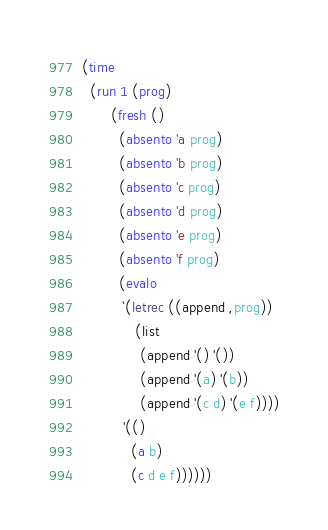Convert code to text. <code><loc_0><loc_0><loc_500><loc_500><_Scheme_>
(time
  (run 1 (prog)
       (fresh ()
         (absento 'a prog)
         (absento 'b prog)
         (absento 'c prog)
         (absento 'd prog)
         (absento 'e prog)
         (absento 'f prog)
         (evalo
          `(letrec ((append ,prog))
             (list
              (append '() '())
              (append '(a) '(b))
              (append '(c d) '(e f))))
          '(()
            (a b)
            (c d e f))))))
</code> 